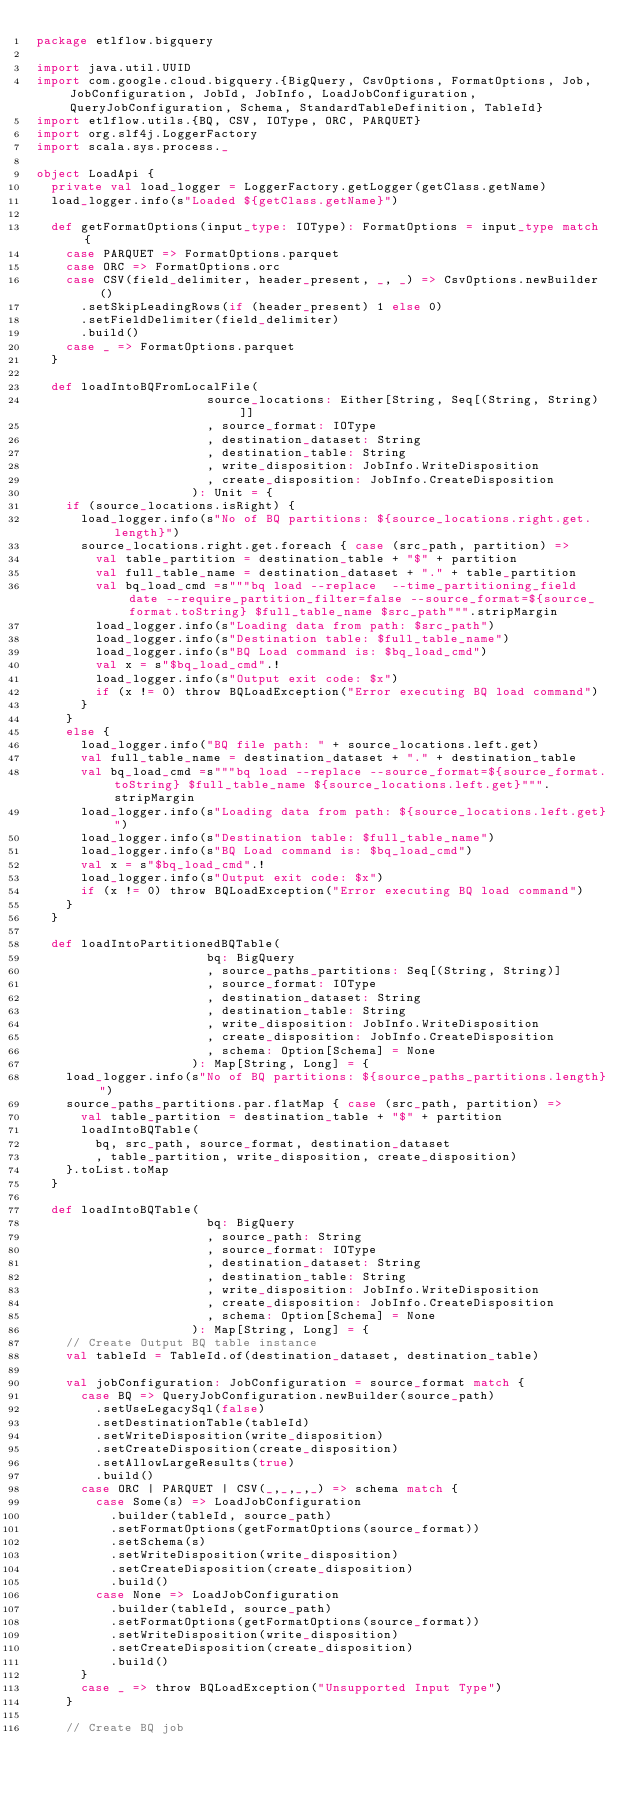<code> <loc_0><loc_0><loc_500><loc_500><_Scala_>package etlflow.bigquery

import java.util.UUID
import com.google.cloud.bigquery.{BigQuery, CsvOptions, FormatOptions, Job, JobConfiguration, JobId, JobInfo, LoadJobConfiguration, QueryJobConfiguration, Schema, StandardTableDefinition, TableId}
import etlflow.utils.{BQ, CSV, IOType, ORC, PARQUET}
import org.slf4j.LoggerFactory
import scala.sys.process._

object LoadApi {
  private val load_logger = LoggerFactory.getLogger(getClass.getName)
  load_logger.info(s"Loaded ${getClass.getName}")

  def getFormatOptions(input_type: IOType): FormatOptions = input_type match {
    case PARQUET => FormatOptions.parquet
    case ORC => FormatOptions.orc
    case CSV(field_delimiter, header_present, _, _) => CsvOptions.newBuilder()
      .setSkipLeadingRows(if (header_present) 1 else 0)
      .setFieldDelimiter(field_delimiter)
      .build()
    case _ => FormatOptions.parquet
  }

  def loadIntoBQFromLocalFile(
                       source_locations: Either[String, Seq[(String, String)]]
                       , source_format: IOType
                       , destination_dataset: String
                       , destination_table: String
                       , write_disposition: JobInfo.WriteDisposition
                       , create_disposition: JobInfo.CreateDisposition
                     ): Unit = {
    if (source_locations.isRight) {
      load_logger.info(s"No of BQ partitions: ${source_locations.right.get.length}")
      source_locations.right.get.foreach { case (src_path, partition) =>
        val table_partition = destination_table + "$" + partition
        val full_table_name = destination_dataset + "." + table_partition
        val bq_load_cmd =s"""bq load --replace  --time_partitioning_field date --require_partition_filter=false --source_format=${source_format.toString} $full_table_name $src_path""".stripMargin
        load_logger.info(s"Loading data from path: $src_path")
        load_logger.info(s"Destination table: $full_table_name")
        load_logger.info(s"BQ Load command is: $bq_load_cmd")
        val x = s"$bq_load_cmd".!
        load_logger.info(s"Output exit code: $x")
        if (x != 0) throw BQLoadException("Error executing BQ load command")
      }
    }
    else {
      load_logger.info("BQ file path: " + source_locations.left.get)
      val full_table_name = destination_dataset + "." + destination_table
      val bq_load_cmd =s"""bq load --replace --source_format=${source_format.toString} $full_table_name ${source_locations.left.get}""".stripMargin
      load_logger.info(s"Loading data from path: ${source_locations.left.get}")
      load_logger.info(s"Destination table: $full_table_name")
      load_logger.info(s"BQ Load command is: $bq_load_cmd")
      val x = s"$bq_load_cmd".!
      load_logger.info(s"Output exit code: $x")
      if (x != 0) throw BQLoadException("Error executing BQ load command")
    }
  }

  def loadIntoPartitionedBQTable(
                       bq: BigQuery
                       , source_paths_partitions: Seq[(String, String)]
                       , source_format: IOType
                       , destination_dataset: String
                       , destination_table: String
                       , write_disposition: JobInfo.WriteDisposition
                       , create_disposition: JobInfo.CreateDisposition
                       , schema: Option[Schema] = None
                     ): Map[String, Long] = {
    load_logger.info(s"No of BQ partitions: ${source_paths_partitions.length}")
    source_paths_partitions.par.flatMap { case (src_path, partition) =>
      val table_partition = destination_table + "$" + partition
      loadIntoBQTable(
        bq, src_path, source_format, destination_dataset
        , table_partition, write_disposition, create_disposition)
    }.toList.toMap
  }

  def loadIntoBQTable(
                       bq: BigQuery
                       , source_path: String
                       , source_format: IOType
                       , destination_dataset: String
                       , destination_table: String
                       , write_disposition: JobInfo.WriteDisposition
                       , create_disposition: JobInfo.CreateDisposition
                       , schema: Option[Schema] = None
                     ): Map[String, Long] = {
    // Create Output BQ table instance
    val tableId = TableId.of(destination_dataset, destination_table)

    val jobConfiguration: JobConfiguration = source_format match {
      case BQ => QueryJobConfiguration.newBuilder(source_path)
        .setUseLegacySql(false)
        .setDestinationTable(tableId)
        .setWriteDisposition(write_disposition)
        .setCreateDisposition(create_disposition)
        .setAllowLargeResults(true)
        .build()
      case ORC | PARQUET | CSV(_,_,_,_) => schema match {
        case Some(s) => LoadJobConfiguration
          .builder(tableId, source_path)
          .setFormatOptions(getFormatOptions(source_format))
          .setSchema(s)
          .setWriteDisposition(write_disposition)
          .setCreateDisposition(create_disposition)
          .build()
        case None => LoadJobConfiguration
          .builder(tableId, source_path)
          .setFormatOptions(getFormatOptions(source_format))
          .setWriteDisposition(write_disposition)
          .setCreateDisposition(create_disposition)
          .build()
      }
      case _ => throw BQLoadException("Unsupported Input Type")
    }

    // Create BQ job</code> 